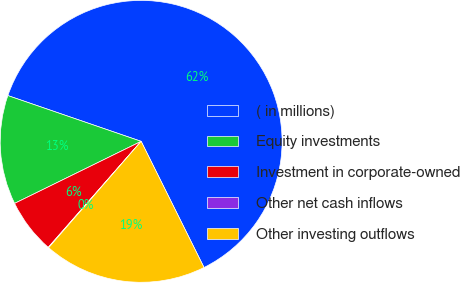<chart> <loc_0><loc_0><loc_500><loc_500><pie_chart><fcel>( in millions)<fcel>Equity investments<fcel>Investment in corporate-owned<fcel>Other net cash inflows<fcel>Other investing outflows<nl><fcel>62.37%<fcel>12.52%<fcel>6.29%<fcel>0.06%<fcel>18.75%<nl></chart> 